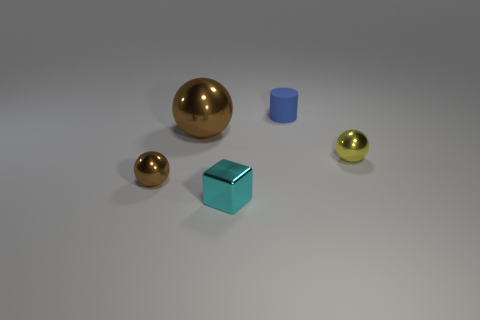Subtract all brown spheres. How many were subtracted if there are1brown spheres left? 1 Add 4 yellow objects. How many objects exist? 9 Subtract all cylinders. How many objects are left? 4 Subtract 0 red spheres. How many objects are left? 5 Subtract all cyan blocks. Subtract all yellow things. How many objects are left? 3 Add 1 large metal things. How many large metal things are left? 2 Add 2 red metal balls. How many red metal balls exist? 2 